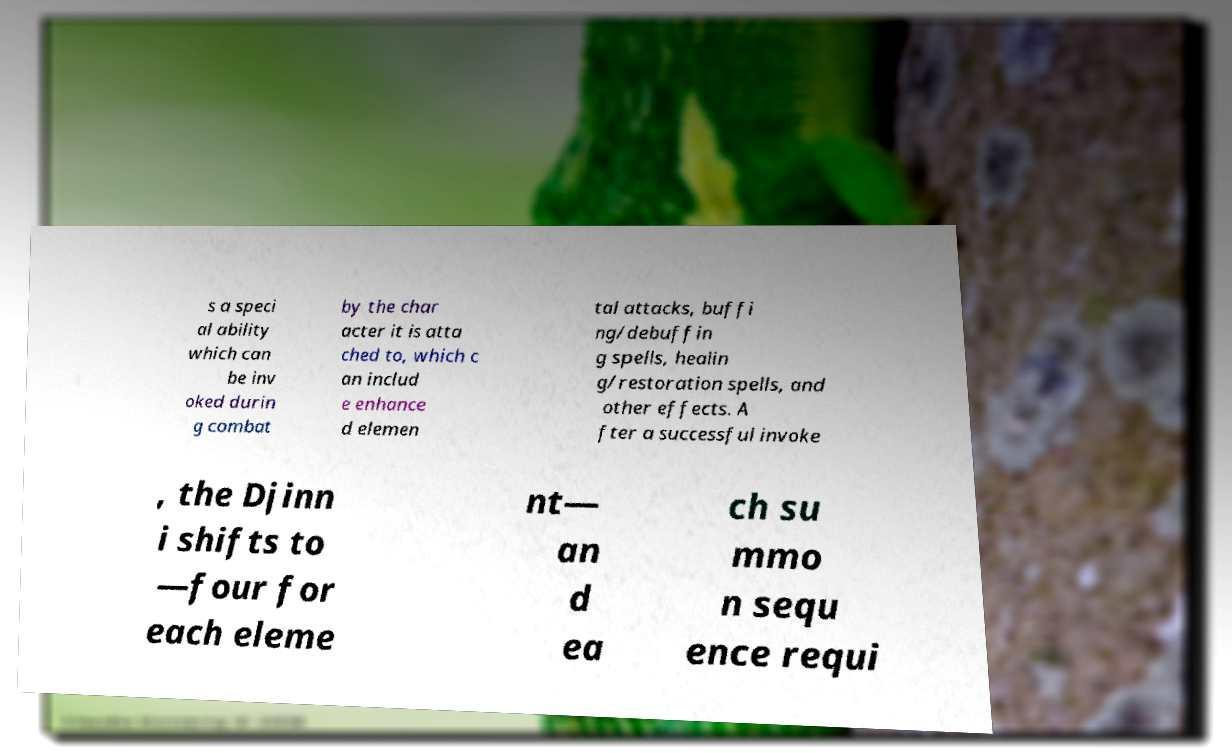Can you accurately transcribe the text from the provided image for me? s a speci al ability which can be inv oked durin g combat by the char acter it is atta ched to, which c an includ e enhance d elemen tal attacks, buffi ng/debuffin g spells, healin g/restoration spells, and other effects. A fter a successful invoke , the Djinn i shifts to —four for each eleme nt— an d ea ch su mmo n sequ ence requi 